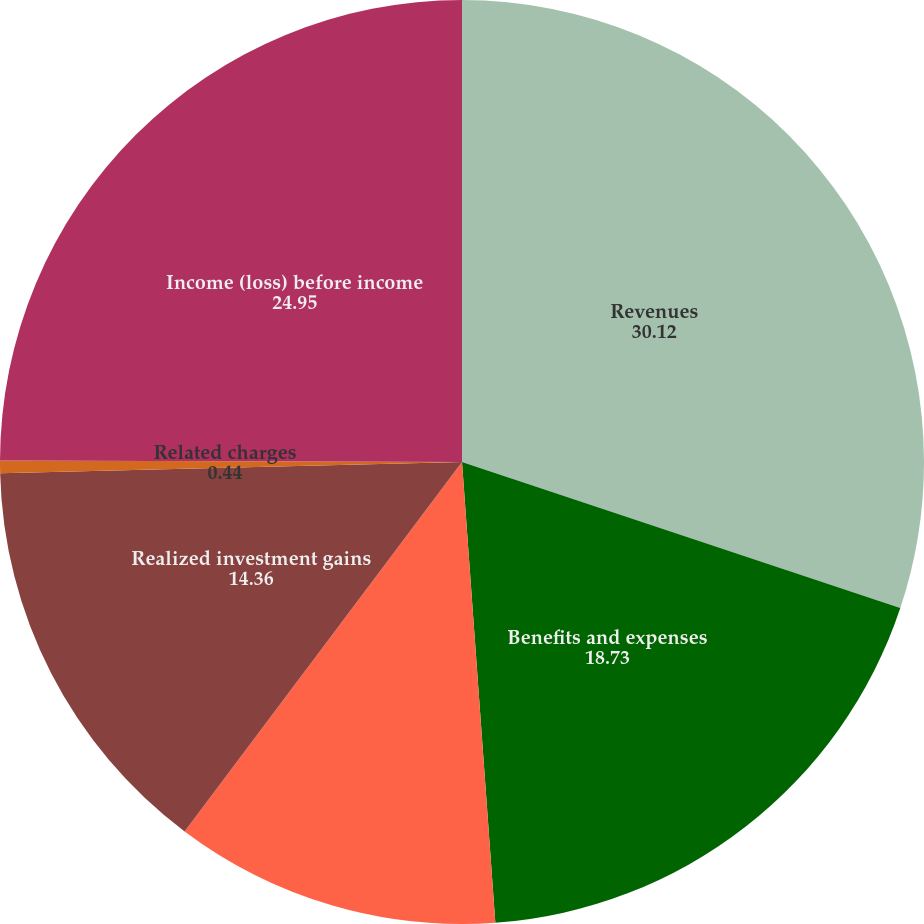<chart> <loc_0><loc_0><loc_500><loc_500><pie_chart><fcel>Revenues<fcel>Benefits and expenses<fcel>Adjusted operating income<fcel>Realized investment gains<fcel>Related charges<fcel>Income (loss) before income<nl><fcel>30.12%<fcel>18.73%<fcel>11.4%<fcel>14.36%<fcel>0.44%<fcel>24.95%<nl></chart> 